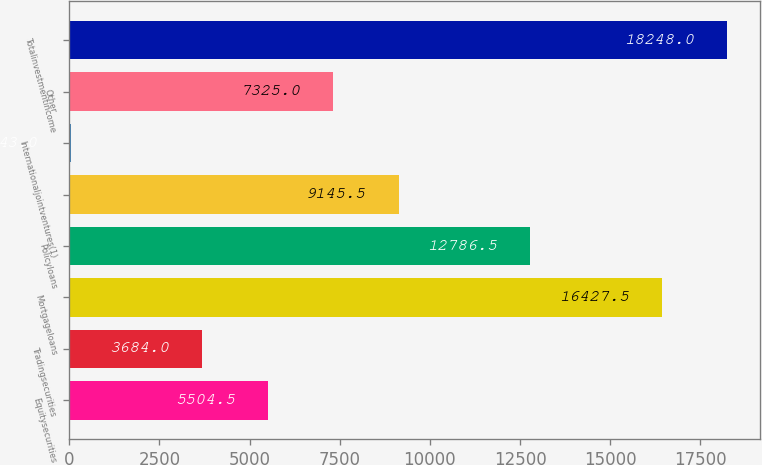<chart> <loc_0><loc_0><loc_500><loc_500><bar_chart><fcel>Equitysecurities<fcel>Tradingsecurities<fcel>Mortgageloans<fcel>Policyloans<fcel>Unnamed: 4<fcel>Internationaljointventures(1)<fcel>Other<fcel>Totalinvestmentincome<nl><fcel>5504.5<fcel>3684<fcel>16427.5<fcel>12786.5<fcel>9145.5<fcel>43<fcel>7325<fcel>18248<nl></chart> 